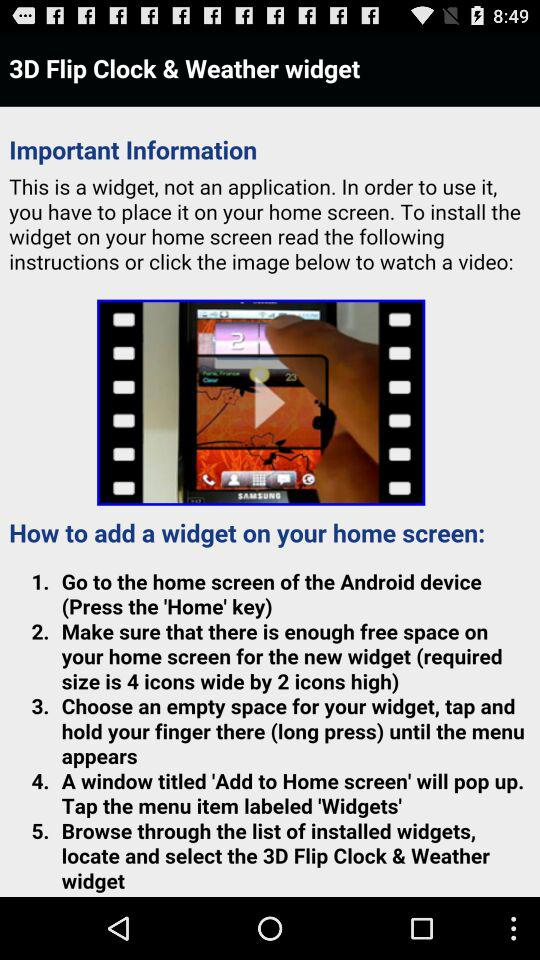What is the application name? The application name is "3D Flip Clock & Weather". 